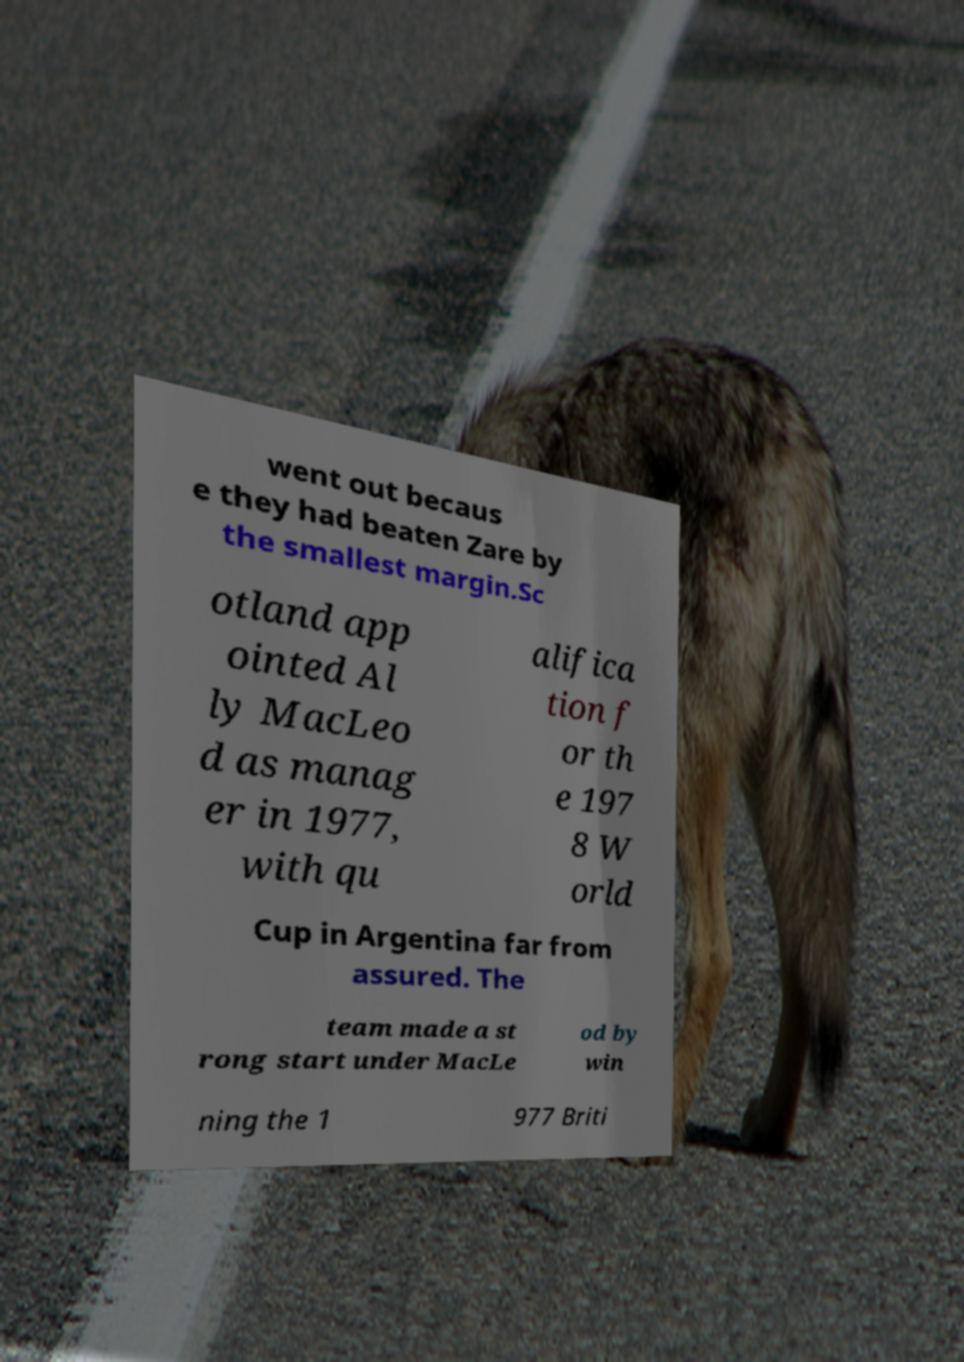Could you extract and type out the text from this image? went out becaus e they had beaten Zare by the smallest margin.Sc otland app ointed Al ly MacLeo d as manag er in 1977, with qu alifica tion f or th e 197 8 W orld Cup in Argentina far from assured. The team made a st rong start under MacLe od by win ning the 1 977 Briti 